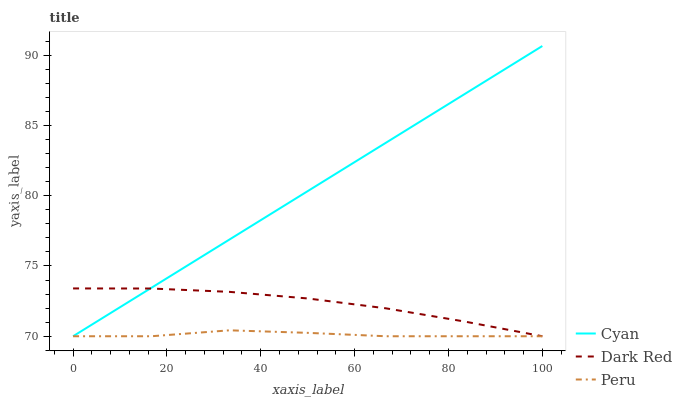Does Peru have the minimum area under the curve?
Answer yes or no. Yes. Does Cyan have the maximum area under the curve?
Answer yes or no. Yes. Does Dark Red have the minimum area under the curve?
Answer yes or no. No. Does Dark Red have the maximum area under the curve?
Answer yes or no. No. Is Cyan the smoothest?
Answer yes or no. Yes. Is Peru the roughest?
Answer yes or no. Yes. Is Dark Red the smoothest?
Answer yes or no. No. Is Dark Red the roughest?
Answer yes or no. No. Does Cyan have the lowest value?
Answer yes or no. Yes. Does Cyan have the highest value?
Answer yes or no. Yes. Does Dark Red have the highest value?
Answer yes or no. No. Does Dark Red intersect Peru?
Answer yes or no. Yes. Is Dark Red less than Peru?
Answer yes or no. No. Is Dark Red greater than Peru?
Answer yes or no. No. 